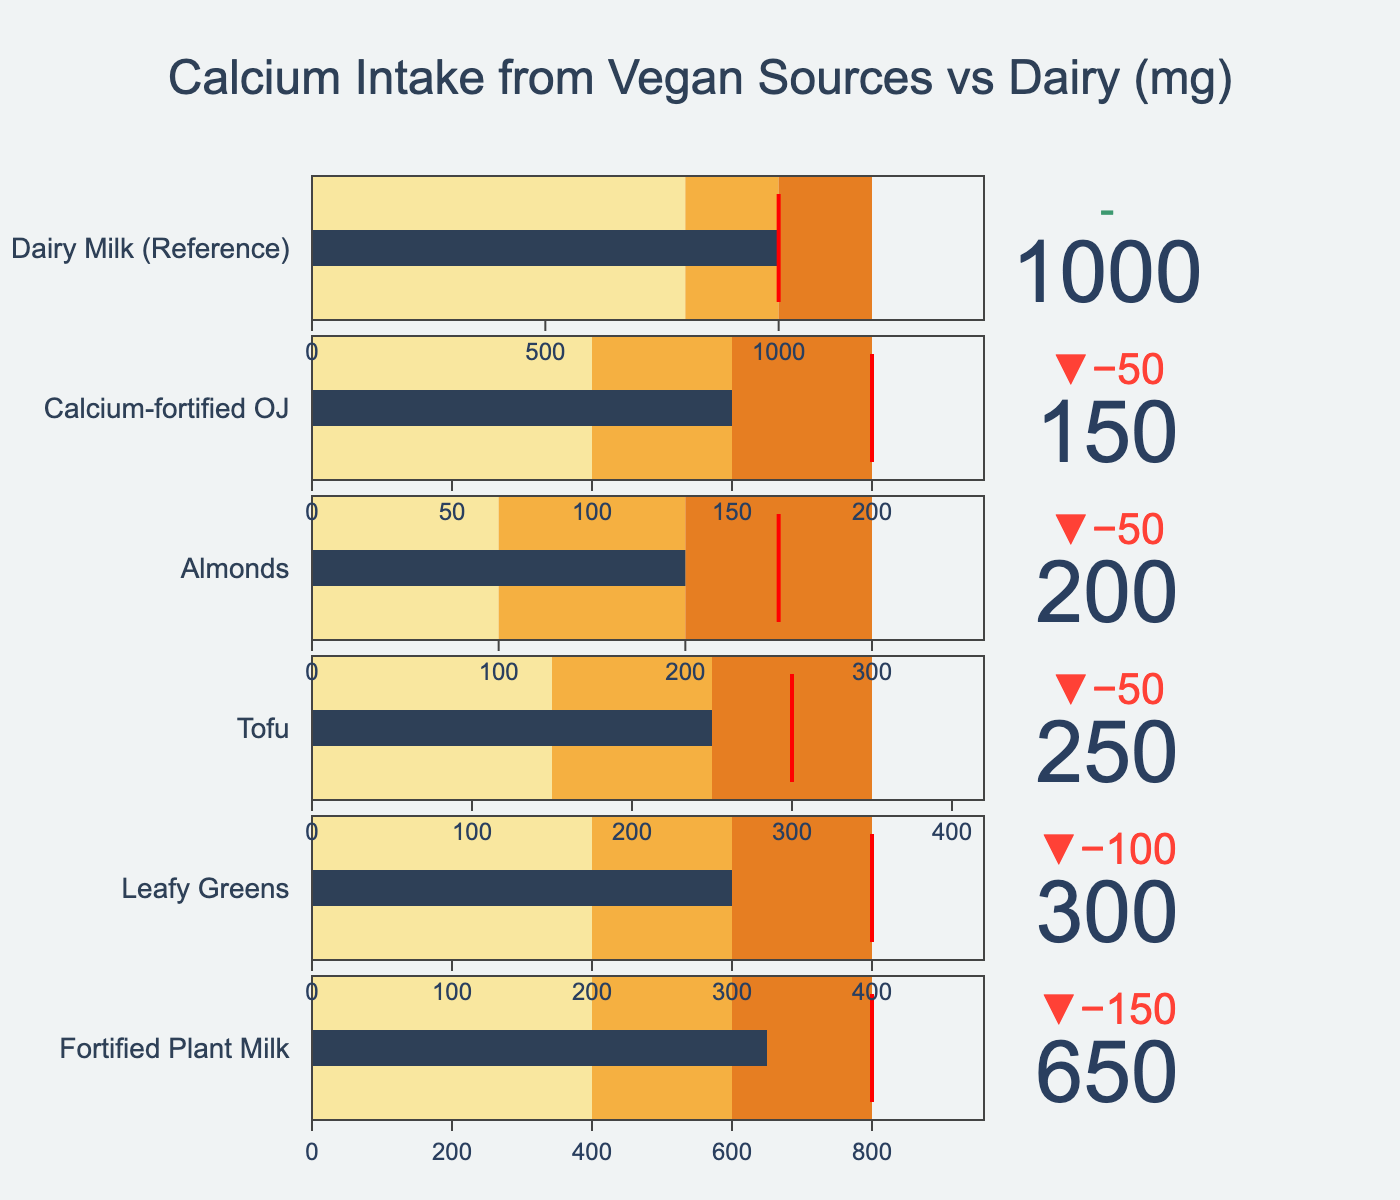How much calcium does Fortified Plant Milk provide compared to its target? The "Actual" value for Fortified Plant Milk is 650 mg and the "Target" value is 800 mg. The difference between these values is 800 mg - 650 mg = 150 mg.
Answer: 150 mg less What is the average actual calcium intake from Leafy Greens and Tofu? The "Actual" values for Leafy Greens and Tofu are 300 mg and 250 mg respectively. The average is calculated as (300 mg + 250 mg) / 2 = 275 mg.
Answer: 275 mg Which vegan source has the greatest actual calcium intake? The "Actual" values from the vegan sources are: Fortified Plant Milk (650 mg), Leafy Greens (300 mg), Tofu (250 mg), Almonds (200 mg), and Calcium-fortified OJ (150 mg). Fortified Plant Milk at 650 mg has the highest value.
Answer: Fortified Plant Milk What is the difference in actual calcium intake between Dairy Milk and Almonds? The "Actual" value for Dairy Milk is 1000 mg and for Almonds is 200 mg. The difference is 1000 mg - 200 mg = 800 mg.
Answer: 800 mg Which category's actual calcium intake is closest to its upper range (Range3)? Fortified Plant Milk has an "Actual" value of 650 mg, and Range3 is 800 mg. Leafy Greens has an "Actual" value of 300 mg, and Range3 is 400 mg. Tofu has an "Actual" value of 250 mg, and Range3 is 350 mg. Almonds have an "Actual" value of 200 mg, and Range3 is 300 mg. Calcium-fortified OJ has an "Actual" value of 150 mg, and Range3 is 200 mg. The closest one is Leafy Greens, with a difference of 100 mg (400 mg - 300 mg = 100 mg).
Answer: Leafy Greens Which source is underperforming the most according to its target? The differences from targets are: Fortified Plant Milk (150 mg below), Leafy Greens (100 mg below), Tofu (50 mg below), Almonds (50 mg below), Calcium-fortified OJ (50 mg below), Dairy Milk (meets target). Fortified Plant Milk underperforms the most by being 150 mg below the target.
Answer: Fortified Plant Milk Which source of calcium is positioned within its optimal range (Range3) in terms of actual intake? According to the "Actual" and "Range3" values: Fortified Plant Milk (650 mg, Range3 is 800 mg), Leafy Greens (300 mg, Range3 is 400 mg), Tofu (250 mg, Range3 is 350 mg), Almonds (200 mg, Range3 is 300 mg), Calcium-fortified OJ (150 mg, Range3 is 200 mg). All listed sources fall within their Range3.
Answer: All sources 